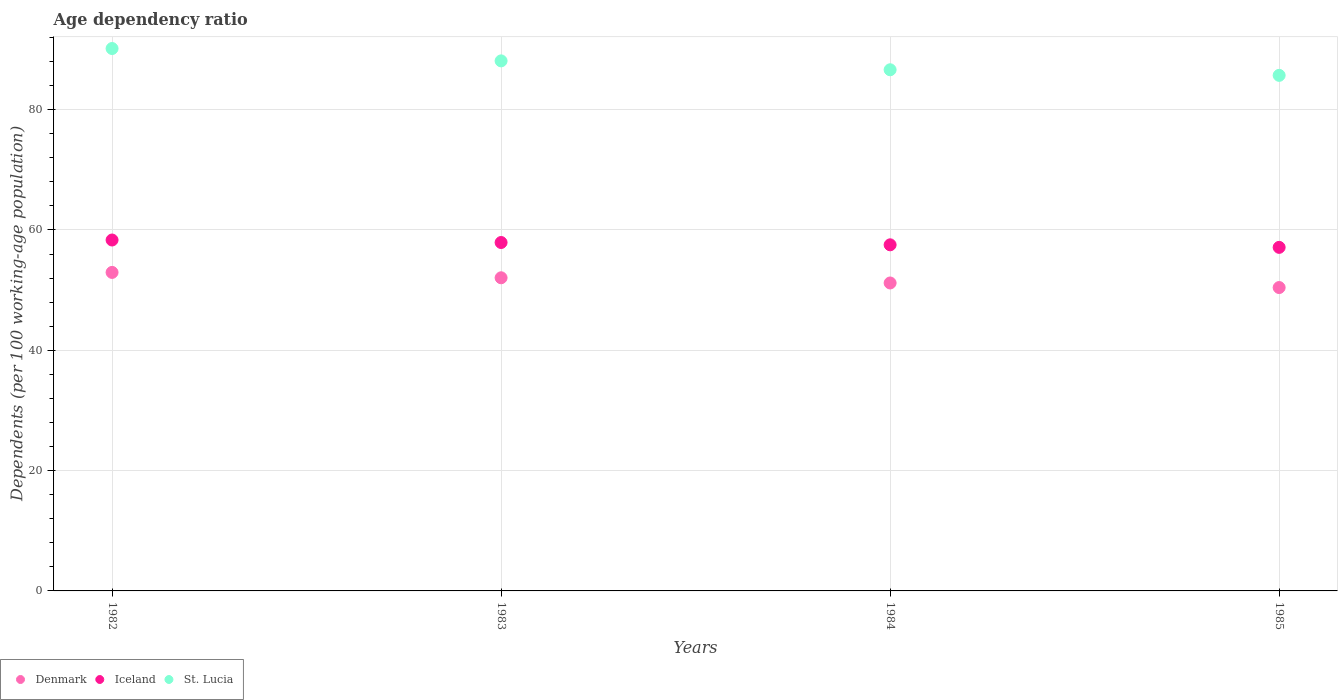Is the number of dotlines equal to the number of legend labels?
Your answer should be very brief. Yes. What is the age dependency ratio in in St. Lucia in 1985?
Provide a short and direct response. 85.7. Across all years, what is the maximum age dependency ratio in in Denmark?
Your answer should be compact. 52.94. Across all years, what is the minimum age dependency ratio in in Iceland?
Offer a terse response. 57.1. What is the total age dependency ratio in in Iceland in the graph?
Your answer should be very brief. 230.87. What is the difference between the age dependency ratio in in St. Lucia in 1984 and that in 1985?
Offer a very short reply. 0.93. What is the difference between the age dependency ratio in in Iceland in 1985 and the age dependency ratio in in St. Lucia in 1983?
Keep it short and to the point. -31. What is the average age dependency ratio in in Iceland per year?
Keep it short and to the point. 57.72. In the year 1985, what is the difference between the age dependency ratio in in St. Lucia and age dependency ratio in in Iceland?
Ensure brevity in your answer.  28.59. What is the ratio of the age dependency ratio in in Iceland in 1983 to that in 1985?
Make the answer very short. 1.01. What is the difference between the highest and the second highest age dependency ratio in in Denmark?
Your response must be concise. 0.89. What is the difference between the highest and the lowest age dependency ratio in in St. Lucia?
Your answer should be compact. 4.46. In how many years, is the age dependency ratio in in St. Lucia greater than the average age dependency ratio in in St. Lucia taken over all years?
Provide a short and direct response. 2. Is the sum of the age dependency ratio in in Denmark in 1982 and 1983 greater than the maximum age dependency ratio in in Iceland across all years?
Give a very brief answer. Yes. Does the age dependency ratio in in Iceland monotonically increase over the years?
Give a very brief answer. No. Is the age dependency ratio in in St. Lucia strictly greater than the age dependency ratio in in Iceland over the years?
Offer a very short reply. Yes. How many dotlines are there?
Keep it short and to the point. 3. How many years are there in the graph?
Offer a very short reply. 4. What is the difference between two consecutive major ticks on the Y-axis?
Your answer should be compact. 20. Are the values on the major ticks of Y-axis written in scientific E-notation?
Your response must be concise. No. Does the graph contain grids?
Your answer should be compact. Yes. Where does the legend appear in the graph?
Provide a succinct answer. Bottom left. What is the title of the graph?
Provide a succinct answer. Age dependency ratio. What is the label or title of the Y-axis?
Make the answer very short. Dependents (per 100 working-age population). What is the Dependents (per 100 working-age population) of Denmark in 1982?
Offer a very short reply. 52.94. What is the Dependents (per 100 working-age population) in Iceland in 1982?
Provide a short and direct response. 58.33. What is the Dependents (per 100 working-age population) of St. Lucia in 1982?
Offer a very short reply. 90.16. What is the Dependents (per 100 working-age population) of Denmark in 1983?
Provide a succinct answer. 52.05. What is the Dependents (per 100 working-age population) of Iceland in 1983?
Provide a succinct answer. 57.91. What is the Dependents (per 100 working-age population) of St. Lucia in 1983?
Provide a short and direct response. 88.1. What is the Dependents (per 100 working-age population) in Denmark in 1984?
Give a very brief answer. 51.19. What is the Dependents (per 100 working-age population) of Iceland in 1984?
Give a very brief answer. 57.53. What is the Dependents (per 100 working-age population) in St. Lucia in 1984?
Provide a short and direct response. 86.63. What is the Dependents (per 100 working-age population) in Denmark in 1985?
Ensure brevity in your answer.  50.43. What is the Dependents (per 100 working-age population) in Iceland in 1985?
Offer a very short reply. 57.1. What is the Dependents (per 100 working-age population) in St. Lucia in 1985?
Your answer should be very brief. 85.7. Across all years, what is the maximum Dependents (per 100 working-age population) of Denmark?
Ensure brevity in your answer.  52.94. Across all years, what is the maximum Dependents (per 100 working-age population) of Iceland?
Your response must be concise. 58.33. Across all years, what is the maximum Dependents (per 100 working-age population) in St. Lucia?
Keep it short and to the point. 90.16. Across all years, what is the minimum Dependents (per 100 working-age population) of Denmark?
Provide a succinct answer. 50.43. Across all years, what is the minimum Dependents (per 100 working-age population) of Iceland?
Offer a very short reply. 57.1. Across all years, what is the minimum Dependents (per 100 working-age population) in St. Lucia?
Make the answer very short. 85.7. What is the total Dependents (per 100 working-age population) of Denmark in the graph?
Provide a succinct answer. 206.6. What is the total Dependents (per 100 working-age population) in Iceland in the graph?
Give a very brief answer. 230.87. What is the total Dependents (per 100 working-age population) of St. Lucia in the graph?
Keep it short and to the point. 350.58. What is the difference between the Dependents (per 100 working-age population) in Denmark in 1982 and that in 1983?
Ensure brevity in your answer.  0.89. What is the difference between the Dependents (per 100 working-age population) of Iceland in 1982 and that in 1983?
Ensure brevity in your answer.  0.42. What is the difference between the Dependents (per 100 working-age population) in St. Lucia in 1982 and that in 1983?
Ensure brevity in your answer.  2.05. What is the difference between the Dependents (per 100 working-age population) of Denmark in 1982 and that in 1984?
Offer a very short reply. 1.75. What is the difference between the Dependents (per 100 working-age population) in Iceland in 1982 and that in 1984?
Provide a short and direct response. 0.8. What is the difference between the Dependents (per 100 working-age population) of St. Lucia in 1982 and that in 1984?
Offer a very short reply. 3.53. What is the difference between the Dependents (per 100 working-age population) of Denmark in 1982 and that in 1985?
Keep it short and to the point. 2.51. What is the difference between the Dependents (per 100 working-age population) in Iceland in 1982 and that in 1985?
Provide a short and direct response. 1.22. What is the difference between the Dependents (per 100 working-age population) in St. Lucia in 1982 and that in 1985?
Provide a succinct answer. 4.46. What is the difference between the Dependents (per 100 working-age population) of Denmark in 1983 and that in 1984?
Provide a succinct answer. 0.86. What is the difference between the Dependents (per 100 working-age population) of Iceland in 1983 and that in 1984?
Provide a succinct answer. 0.38. What is the difference between the Dependents (per 100 working-age population) of St. Lucia in 1983 and that in 1984?
Your response must be concise. 1.48. What is the difference between the Dependents (per 100 working-age population) in Denmark in 1983 and that in 1985?
Provide a short and direct response. 1.62. What is the difference between the Dependents (per 100 working-age population) in Iceland in 1983 and that in 1985?
Offer a very short reply. 0.81. What is the difference between the Dependents (per 100 working-age population) of St. Lucia in 1983 and that in 1985?
Your answer should be very brief. 2.41. What is the difference between the Dependents (per 100 working-age population) in Denmark in 1984 and that in 1985?
Give a very brief answer. 0.76. What is the difference between the Dependents (per 100 working-age population) of Iceland in 1984 and that in 1985?
Make the answer very short. 0.42. What is the difference between the Dependents (per 100 working-age population) in St. Lucia in 1984 and that in 1985?
Your answer should be very brief. 0.93. What is the difference between the Dependents (per 100 working-age population) of Denmark in 1982 and the Dependents (per 100 working-age population) of Iceland in 1983?
Offer a terse response. -4.97. What is the difference between the Dependents (per 100 working-age population) of Denmark in 1982 and the Dependents (per 100 working-age population) of St. Lucia in 1983?
Provide a short and direct response. -35.16. What is the difference between the Dependents (per 100 working-age population) of Iceland in 1982 and the Dependents (per 100 working-age population) of St. Lucia in 1983?
Provide a succinct answer. -29.77. What is the difference between the Dependents (per 100 working-age population) in Denmark in 1982 and the Dependents (per 100 working-age population) in Iceland in 1984?
Keep it short and to the point. -4.59. What is the difference between the Dependents (per 100 working-age population) in Denmark in 1982 and the Dependents (per 100 working-age population) in St. Lucia in 1984?
Offer a terse response. -33.68. What is the difference between the Dependents (per 100 working-age population) of Iceland in 1982 and the Dependents (per 100 working-age population) of St. Lucia in 1984?
Your answer should be very brief. -28.3. What is the difference between the Dependents (per 100 working-age population) in Denmark in 1982 and the Dependents (per 100 working-age population) in Iceland in 1985?
Ensure brevity in your answer.  -4.16. What is the difference between the Dependents (per 100 working-age population) of Denmark in 1982 and the Dependents (per 100 working-age population) of St. Lucia in 1985?
Provide a succinct answer. -32.75. What is the difference between the Dependents (per 100 working-age population) of Iceland in 1982 and the Dependents (per 100 working-age population) of St. Lucia in 1985?
Provide a succinct answer. -27.37. What is the difference between the Dependents (per 100 working-age population) in Denmark in 1983 and the Dependents (per 100 working-age population) in Iceland in 1984?
Provide a succinct answer. -5.48. What is the difference between the Dependents (per 100 working-age population) of Denmark in 1983 and the Dependents (per 100 working-age population) of St. Lucia in 1984?
Provide a short and direct response. -34.58. What is the difference between the Dependents (per 100 working-age population) of Iceland in 1983 and the Dependents (per 100 working-age population) of St. Lucia in 1984?
Offer a terse response. -28.71. What is the difference between the Dependents (per 100 working-age population) in Denmark in 1983 and the Dependents (per 100 working-age population) in Iceland in 1985?
Give a very brief answer. -5.06. What is the difference between the Dependents (per 100 working-age population) of Denmark in 1983 and the Dependents (per 100 working-age population) of St. Lucia in 1985?
Your answer should be very brief. -33.65. What is the difference between the Dependents (per 100 working-age population) of Iceland in 1983 and the Dependents (per 100 working-age population) of St. Lucia in 1985?
Provide a succinct answer. -27.78. What is the difference between the Dependents (per 100 working-age population) in Denmark in 1984 and the Dependents (per 100 working-age population) in Iceland in 1985?
Give a very brief answer. -5.92. What is the difference between the Dependents (per 100 working-age population) of Denmark in 1984 and the Dependents (per 100 working-age population) of St. Lucia in 1985?
Your answer should be compact. -34.51. What is the difference between the Dependents (per 100 working-age population) of Iceland in 1984 and the Dependents (per 100 working-age population) of St. Lucia in 1985?
Your response must be concise. -28.17. What is the average Dependents (per 100 working-age population) in Denmark per year?
Your answer should be compact. 51.65. What is the average Dependents (per 100 working-age population) of Iceland per year?
Offer a very short reply. 57.72. What is the average Dependents (per 100 working-age population) in St. Lucia per year?
Your answer should be compact. 87.64. In the year 1982, what is the difference between the Dependents (per 100 working-age population) in Denmark and Dependents (per 100 working-age population) in Iceland?
Ensure brevity in your answer.  -5.39. In the year 1982, what is the difference between the Dependents (per 100 working-age population) of Denmark and Dependents (per 100 working-age population) of St. Lucia?
Offer a very short reply. -37.21. In the year 1982, what is the difference between the Dependents (per 100 working-age population) of Iceland and Dependents (per 100 working-age population) of St. Lucia?
Offer a very short reply. -31.83. In the year 1983, what is the difference between the Dependents (per 100 working-age population) in Denmark and Dependents (per 100 working-age population) in Iceland?
Ensure brevity in your answer.  -5.86. In the year 1983, what is the difference between the Dependents (per 100 working-age population) of Denmark and Dependents (per 100 working-age population) of St. Lucia?
Ensure brevity in your answer.  -36.05. In the year 1983, what is the difference between the Dependents (per 100 working-age population) in Iceland and Dependents (per 100 working-age population) in St. Lucia?
Ensure brevity in your answer.  -30.19. In the year 1984, what is the difference between the Dependents (per 100 working-age population) in Denmark and Dependents (per 100 working-age population) in Iceland?
Give a very brief answer. -6.34. In the year 1984, what is the difference between the Dependents (per 100 working-age population) in Denmark and Dependents (per 100 working-age population) in St. Lucia?
Offer a terse response. -35.44. In the year 1984, what is the difference between the Dependents (per 100 working-age population) of Iceland and Dependents (per 100 working-age population) of St. Lucia?
Your response must be concise. -29.1. In the year 1985, what is the difference between the Dependents (per 100 working-age population) of Denmark and Dependents (per 100 working-age population) of Iceland?
Give a very brief answer. -6.68. In the year 1985, what is the difference between the Dependents (per 100 working-age population) of Denmark and Dependents (per 100 working-age population) of St. Lucia?
Provide a short and direct response. -35.27. In the year 1985, what is the difference between the Dependents (per 100 working-age population) in Iceland and Dependents (per 100 working-age population) in St. Lucia?
Your answer should be compact. -28.59. What is the ratio of the Dependents (per 100 working-age population) in Denmark in 1982 to that in 1983?
Provide a short and direct response. 1.02. What is the ratio of the Dependents (per 100 working-age population) of Iceland in 1982 to that in 1983?
Provide a short and direct response. 1.01. What is the ratio of the Dependents (per 100 working-age population) of St. Lucia in 1982 to that in 1983?
Provide a short and direct response. 1.02. What is the ratio of the Dependents (per 100 working-age population) of Denmark in 1982 to that in 1984?
Provide a succinct answer. 1.03. What is the ratio of the Dependents (per 100 working-age population) of Iceland in 1982 to that in 1984?
Offer a terse response. 1.01. What is the ratio of the Dependents (per 100 working-age population) of St. Lucia in 1982 to that in 1984?
Your answer should be compact. 1.04. What is the ratio of the Dependents (per 100 working-age population) in Denmark in 1982 to that in 1985?
Offer a very short reply. 1.05. What is the ratio of the Dependents (per 100 working-age population) in Iceland in 1982 to that in 1985?
Your response must be concise. 1.02. What is the ratio of the Dependents (per 100 working-age population) in St. Lucia in 1982 to that in 1985?
Provide a succinct answer. 1.05. What is the ratio of the Dependents (per 100 working-age population) in Denmark in 1983 to that in 1984?
Your answer should be very brief. 1.02. What is the ratio of the Dependents (per 100 working-age population) in Denmark in 1983 to that in 1985?
Your response must be concise. 1.03. What is the ratio of the Dependents (per 100 working-age population) of Iceland in 1983 to that in 1985?
Make the answer very short. 1.01. What is the ratio of the Dependents (per 100 working-age population) of St. Lucia in 1983 to that in 1985?
Give a very brief answer. 1.03. What is the ratio of the Dependents (per 100 working-age population) of Denmark in 1984 to that in 1985?
Ensure brevity in your answer.  1.02. What is the ratio of the Dependents (per 100 working-age population) in Iceland in 1984 to that in 1985?
Provide a short and direct response. 1.01. What is the ratio of the Dependents (per 100 working-age population) of St. Lucia in 1984 to that in 1985?
Your answer should be very brief. 1.01. What is the difference between the highest and the second highest Dependents (per 100 working-age population) in Denmark?
Ensure brevity in your answer.  0.89. What is the difference between the highest and the second highest Dependents (per 100 working-age population) of Iceland?
Give a very brief answer. 0.42. What is the difference between the highest and the second highest Dependents (per 100 working-age population) of St. Lucia?
Keep it short and to the point. 2.05. What is the difference between the highest and the lowest Dependents (per 100 working-age population) in Denmark?
Your answer should be very brief. 2.51. What is the difference between the highest and the lowest Dependents (per 100 working-age population) in Iceland?
Make the answer very short. 1.22. What is the difference between the highest and the lowest Dependents (per 100 working-age population) of St. Lucia?
Make the answer very short. 4.46. 